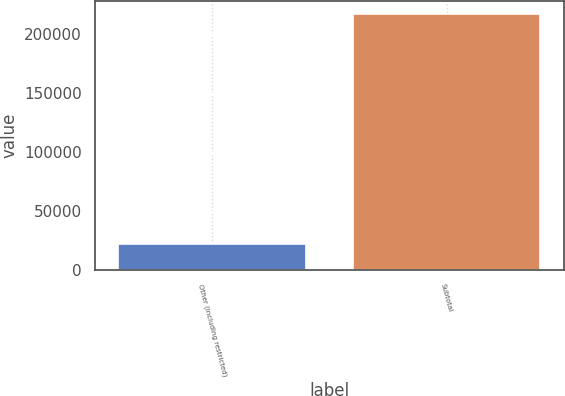Convert chart. <chart><loc_0><loc_0><loc_500><loc_500><bar_chart><fcel>Other (including restricted)<fcel>Subtotal<nl><fcel>21835<fcel>216857<nl></chart> 